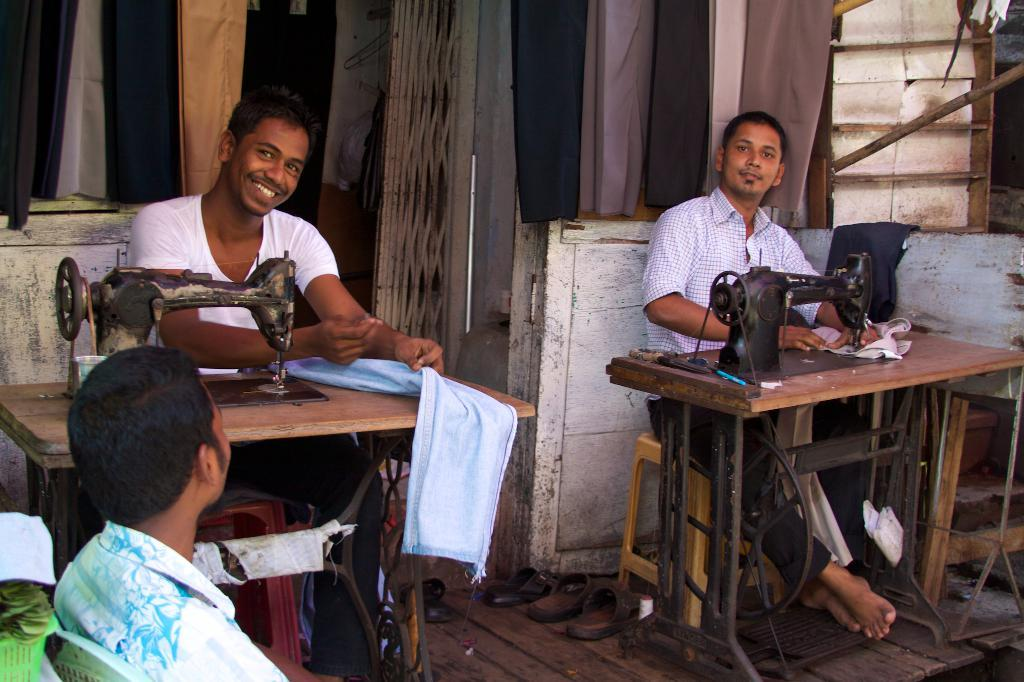How many men are in the image? There are three men in the image. What are the positions of the men in the image? Two of the men are sitting, while the third man's position is not mentioned. What are the sitting men doing? The two sitting men are in front of sewing machines. What type of experience does the toad have with sewing machines in the image? There is no toad present in the image, so it is not possible to determine any experience with sewing machines. 